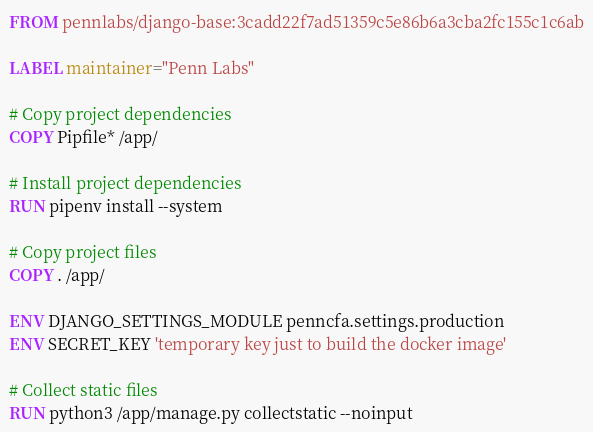<code> <loc_0><loc_0><loc_500><loc_500><_Dockerfile_>FROM pennlabs/django-base:3cadd22f7ad51359c5e86b6a3cba2fc155c1c6ab

LABEL maintainer="Penn Labs"

# Copy project dependencies
COPY Pipfile* /app/

# Install project dependencies
RUN pipenv install --system

# Copy project files
COPY . /app/

ENV DJANGO_SETTINGS_MODULE penncfa.settings.production
ENV SECRET_KEY 'temporary key just to build the docker image'

# Collect static files
RUN python3 /app/manage.py collectstatic --noinput
</code> 